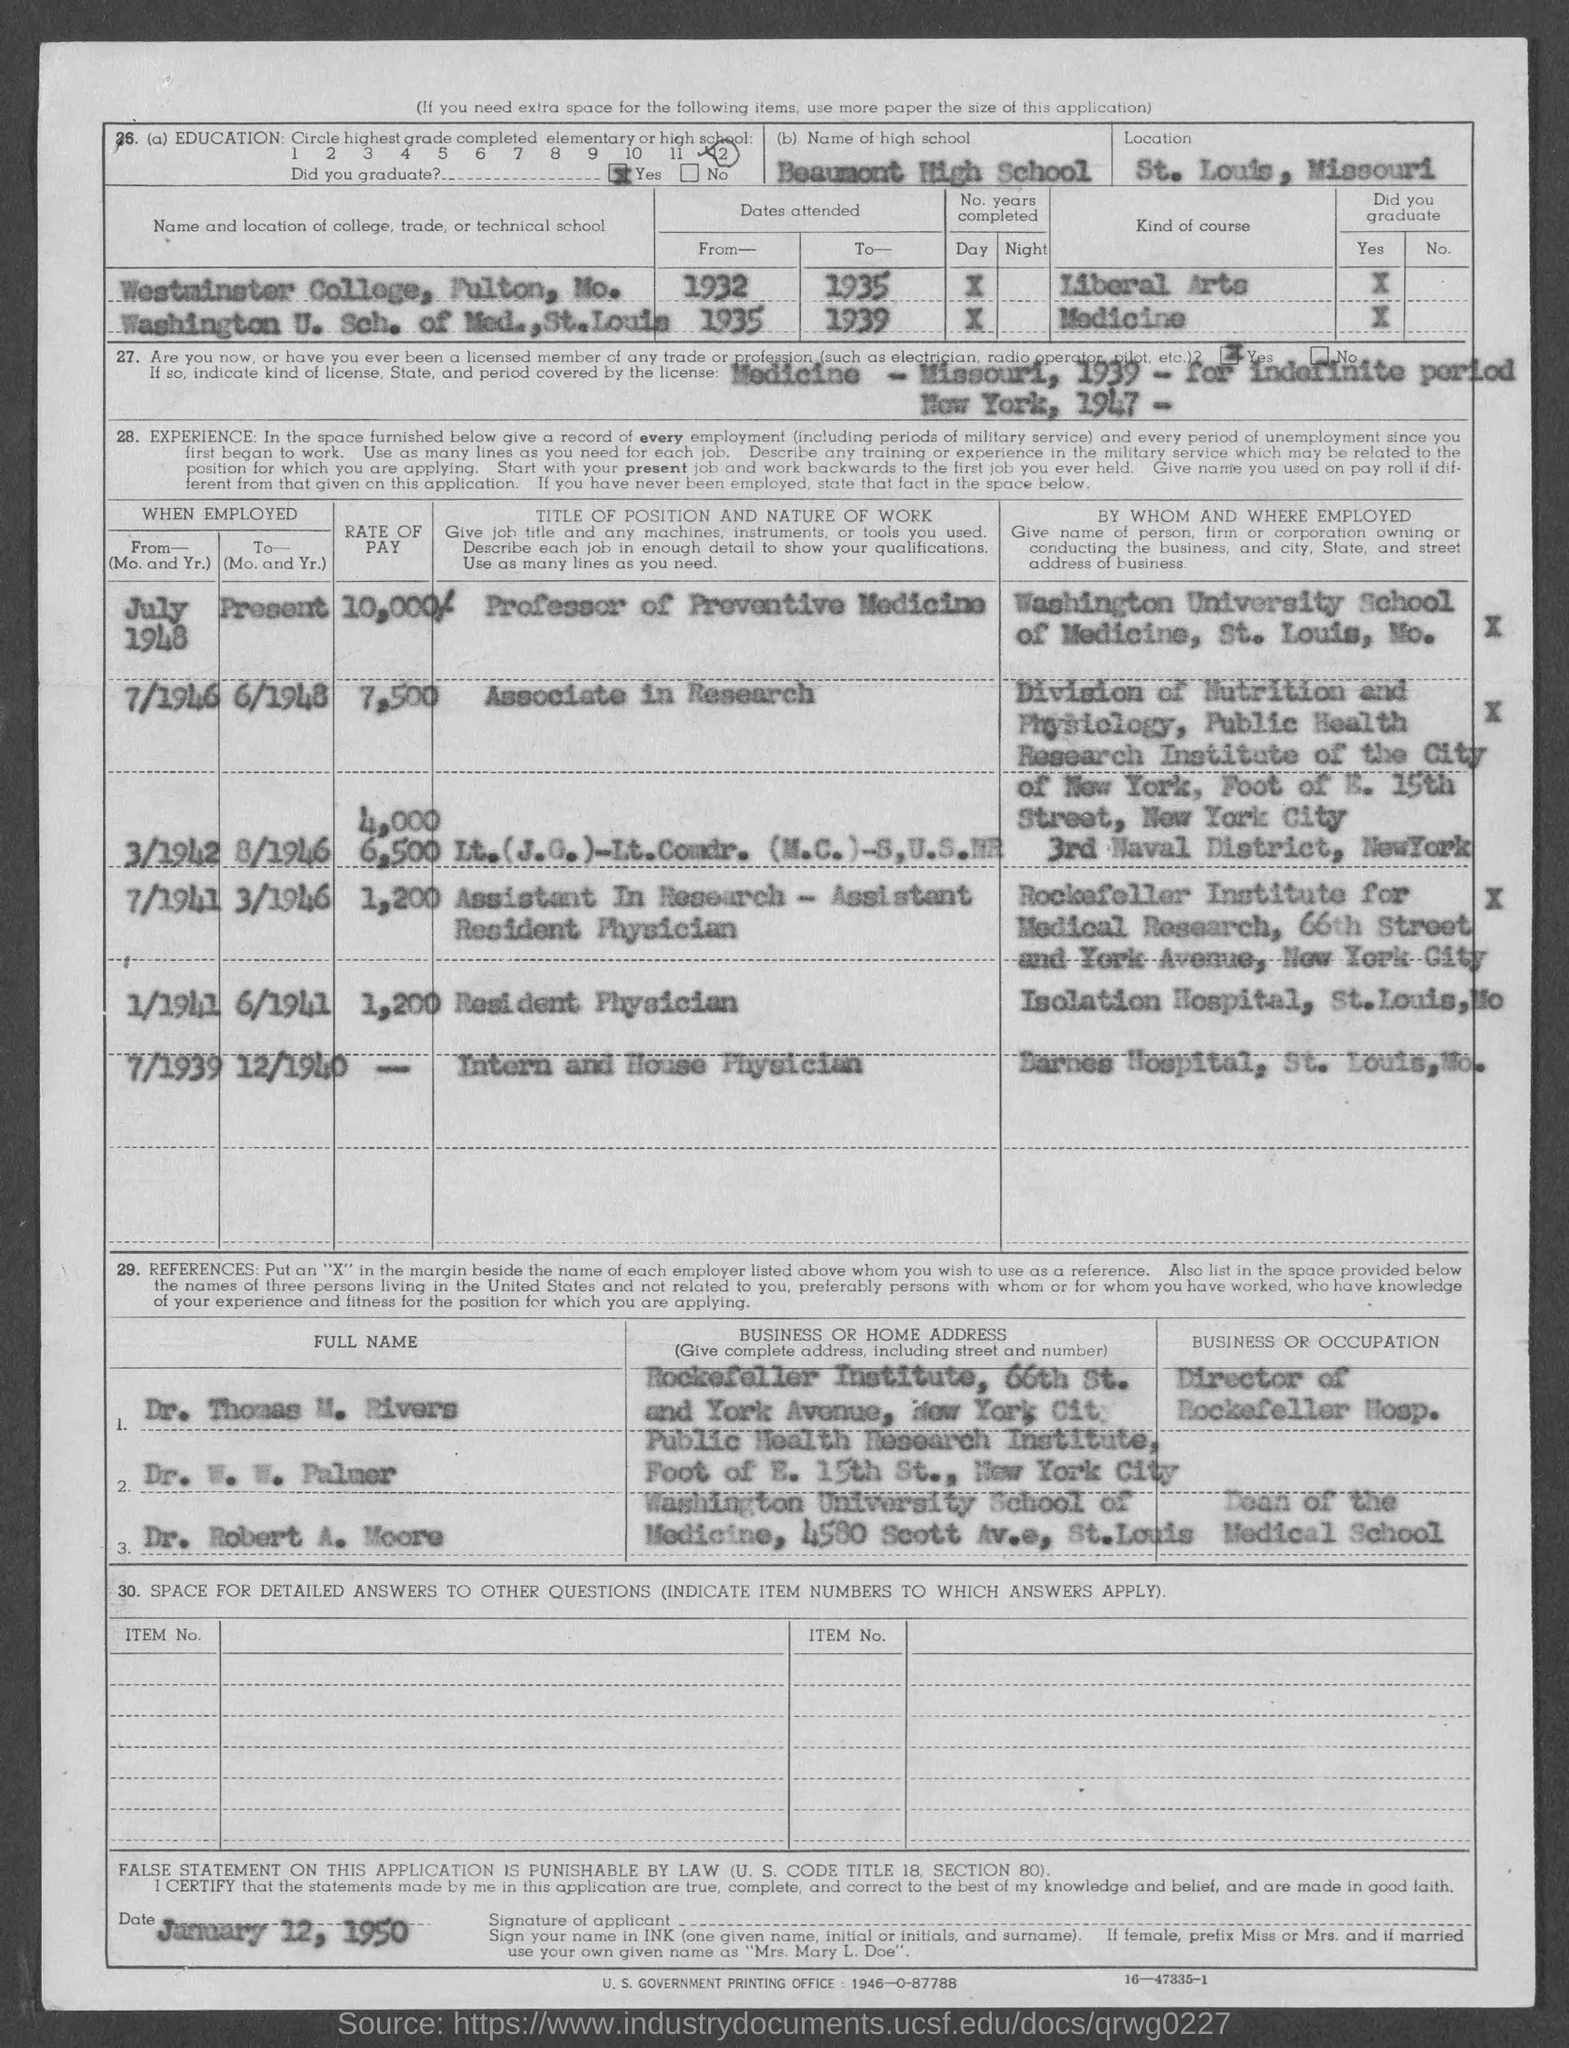Specify some key components in this picture. From July 1948 to present, the rate of pay has been 10,000/-. From 1946 to 1948, I held the position of Associate in Research. I would like to declare that the high school mentioned is Beaumont High School. The Director of Rockefeller Hospital is Dr. Thomas M. Rivers. The document is dated January 12, 1950. 